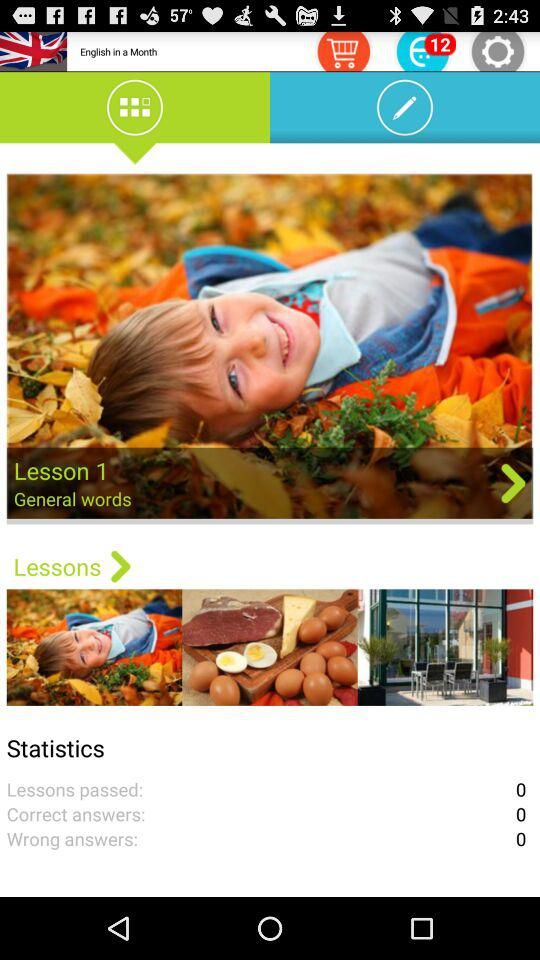How many answers are wrong? There are 0 wrong answers. 